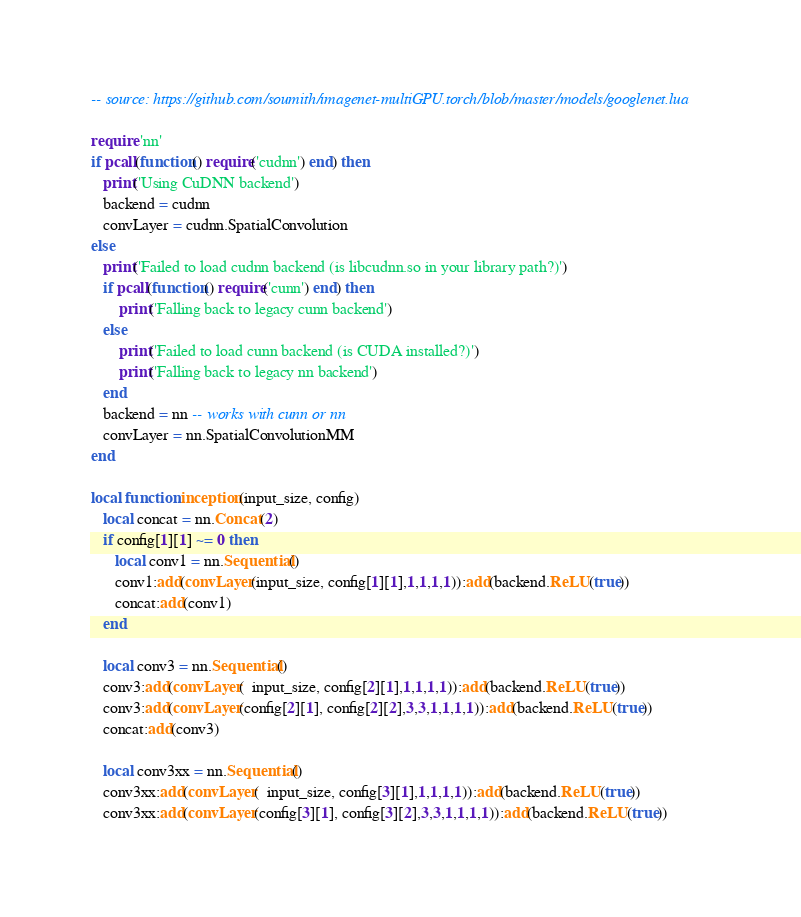Convert code to text. <code><loc_0><loc_0><loc_500><loc_500><_Lua_>-- source: https://github.com/soumith/imagenet-multiGPU.torch/blob/master/models/googlenet.lua

require 'nn'
if pcall(function() require('cudnn') end) then
   print('Using CuDNN backend')
   backend = cudnn
   convLayer = cudnn.SpatialConvolution
else
   print('Failed to load cudnn backend (is libcudnn.so in your library path?)')
   if pcall(function() require('cunn') end) then
       print('Falling back to legacy cunn backend')
   else
       print('Failed to load cunn backend (is CUDA installed?)')
       print('Falling back to legacy nn backend')
   end
   backend = nn -- works with cunn or nn
   convLayer = nn.SpatialConvolutionMM
end

local function inception(input_size, config)
   local concat = nn.Concat(2)
   if config[1][1] ~= 0 then
      local conv1 = nn.Sequential()
      conv1:add(convLayer(input_size, config[1][1],1,1,1,1)):add(backend.ReLU(true))
      concat:add(conv1)
   end

   local conv3 = nn.Sequential()
   conv3:add(convLayer(  input_size, config[2][1],1,1,1,1)):add(backend.ReLU(true))
   conv3:add(convLayer(config[2][1], config[2][2],3,3,1,1,1,1)):add(backend.ReLU(true))
   concat:add(conv3)

   local conv3xx = nn.Sequential()
   conv3xx:add(convLayer(  input_size, config[3][1],1,1,1,1)):add(backend.ReLU(true))
   conv3xx:add(convLayer(config[3][1], config[3][2],3,3,1,1,1,1)):add(backend.ReLU(true))</code> 